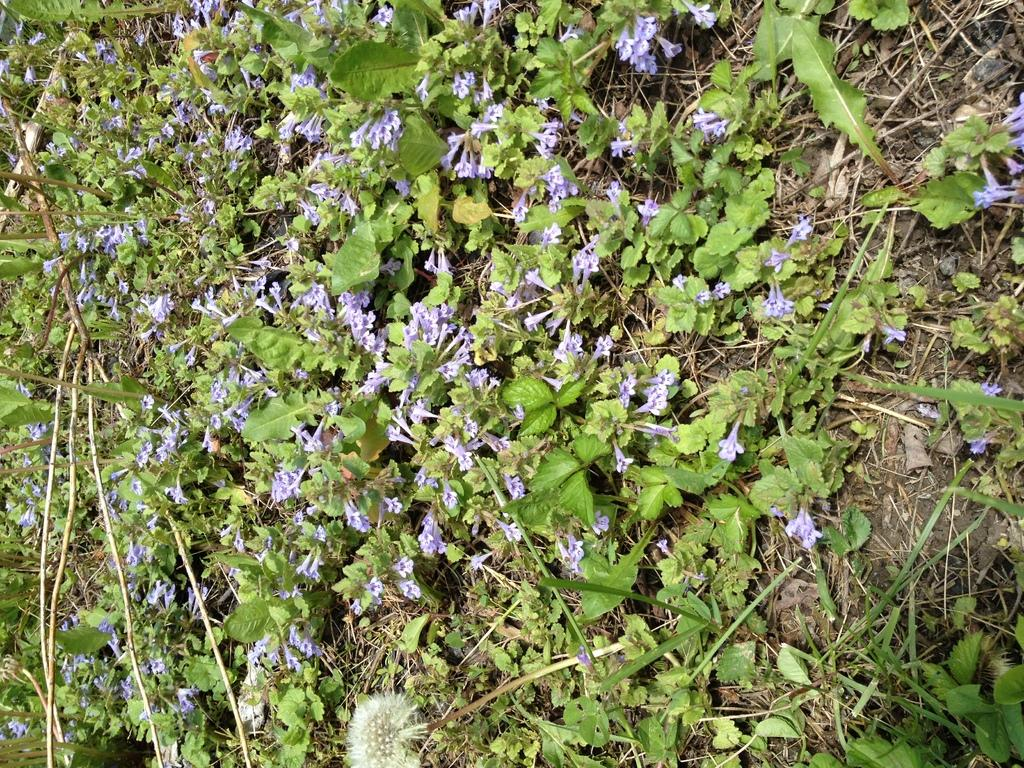What type of living organisms can be seen in the image? Plants can be seen in the image. What color are the flowers on the plants? The flowers on the plants have a violet color. What type of trouble can be seen in the image? There is no trouble present in the image; it features plants with violet flowers. What type of fruit is associated with the quince in the image? There is no quince present in the image, so it cannot be associated with any fruit. 